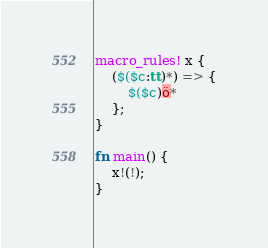<code> <loc_0><loc_0><loc_500><loc_500><_Rust_>macro_rules! x {
    ($($c:tt)*) => {
        $($c)ö*
    };
}

fn main() {
    x!(!);
}
</code> 